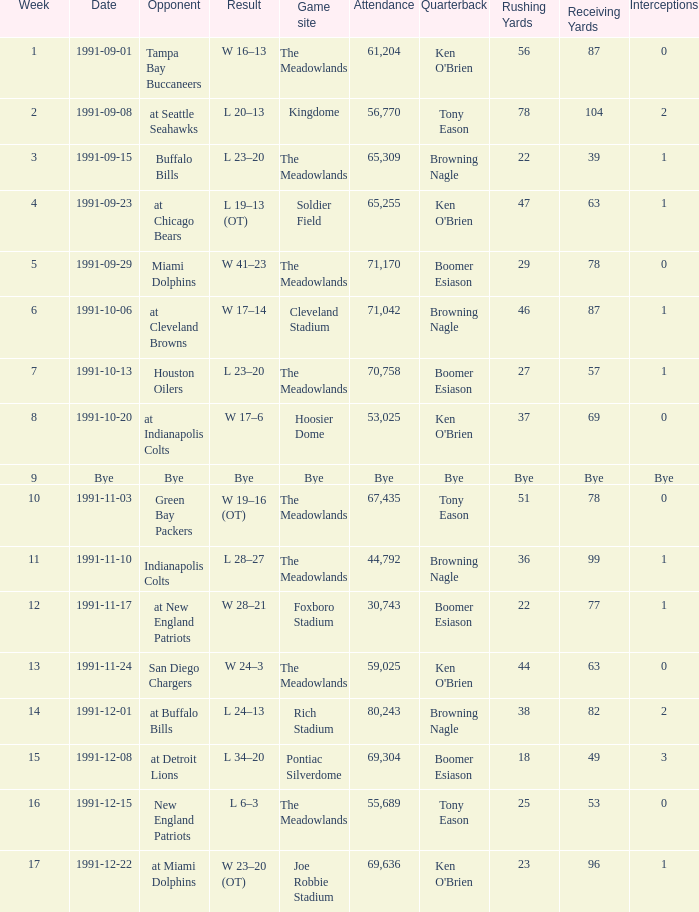Which Opponent was played on 1991-10-13? Houston Oilers. 